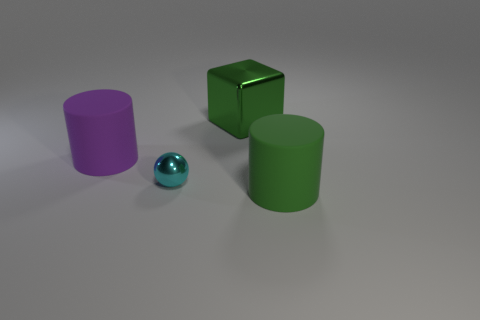There is a cylinder that is to the left of the large metallic cube; are there any purple matte things behind it?
Your response must be concise. No. What number of big objects are the same color as the big metal cube?
Provide a short and direct response. 1. What is the material of the other big object that is the same color as the big metal object?
Keep it short and to the point. Rubber. Are the cyan object and the big green block made of the same material?
Ensure brevity in your answer.  Yes. Are there any green metal cubes in front of the tiny object?
Your answer should be very brief. No. There is a cylinder that is to the left of the green thing that is behind the tiny cyan shiny object; what is its material?
Give a very brief answer. Rubber. There is another object that is the same shape as the big green rubber thing; what size is it?
Offer a very short reply. Large. Does the large metallic block have the same color as the metal ball?
Offer a terse response. No. The big thing that is behind the small cyan thing and right of the large purple rubber cylinder is what color?
Offer a terse response. Green. Is the size of the rubber object that is on the right side of the block the same as the cyan object?
Offer a terse response. No. 